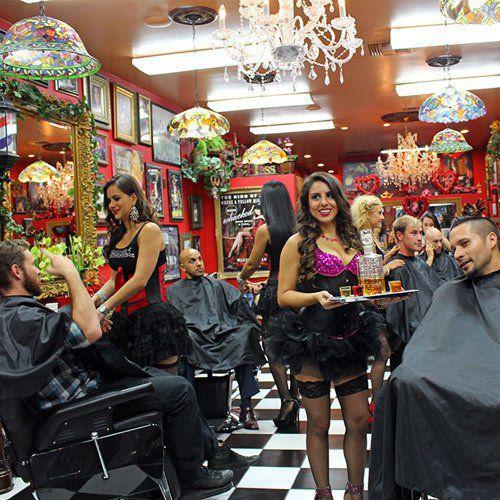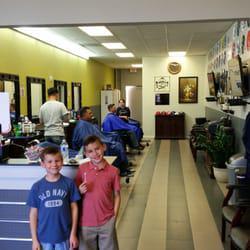The first image is the image on the left, the second image is the image on the right. Analyze the images presented: Is the assertion "In at least one image there are two boys side by side in a barber shop." valid? Answer yes or no. Yes. The first image is the image on the left, the second image is the image on the right. For the images displayed, is the sentence "An image shows two young boys standing side-by-side and facing forward." factually correct? Answer yes or no. Yes. 